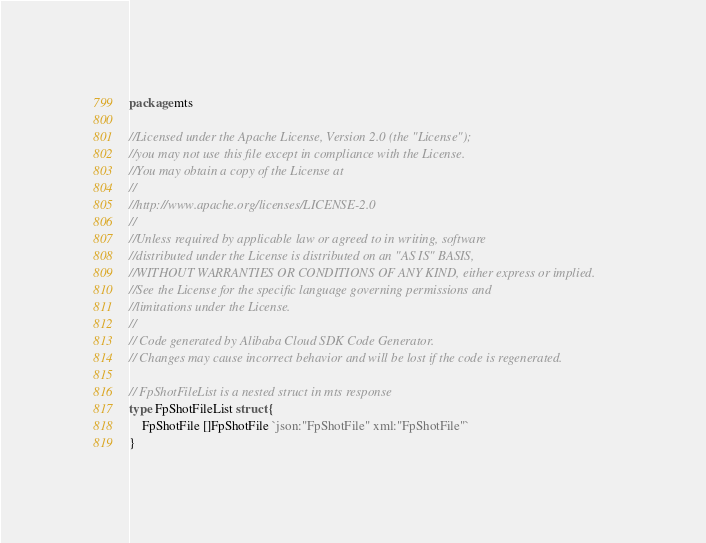Convert code to text. <code><loc_0><loc_0><loc_500><loc_500><_Go_>package mts

//Licensed under the Apache License, Version 2.0 (the "License");
//you may not use this file except in compliance with the License.
//You may obtain a copy of the License at
//
//http://www.apache.org/licenses/LICENSE-2.0
//
//Unless required by applicable law or agreed to in writing, software
//distributed under the License is distributed on an "AS IS" BASIS,
//WITHOUT WARRANTIES OR CONDITIONS OF ANY KIND, either express or implied.
//See the License for the specific language governing permissions and
//limitations under the License.
//
// Code generated by Alibaba Cloud SDK Code Generator.
// Changes may cause incorrect behavior and will be lost if the code is regenerated.

// FpShotFileList is a nested struct in mts response
type FpShotFileList struct {
	FpShotFile []FpShotFile `json:"FpShotFile" xml:"FpShotFile"`
}
</code> 